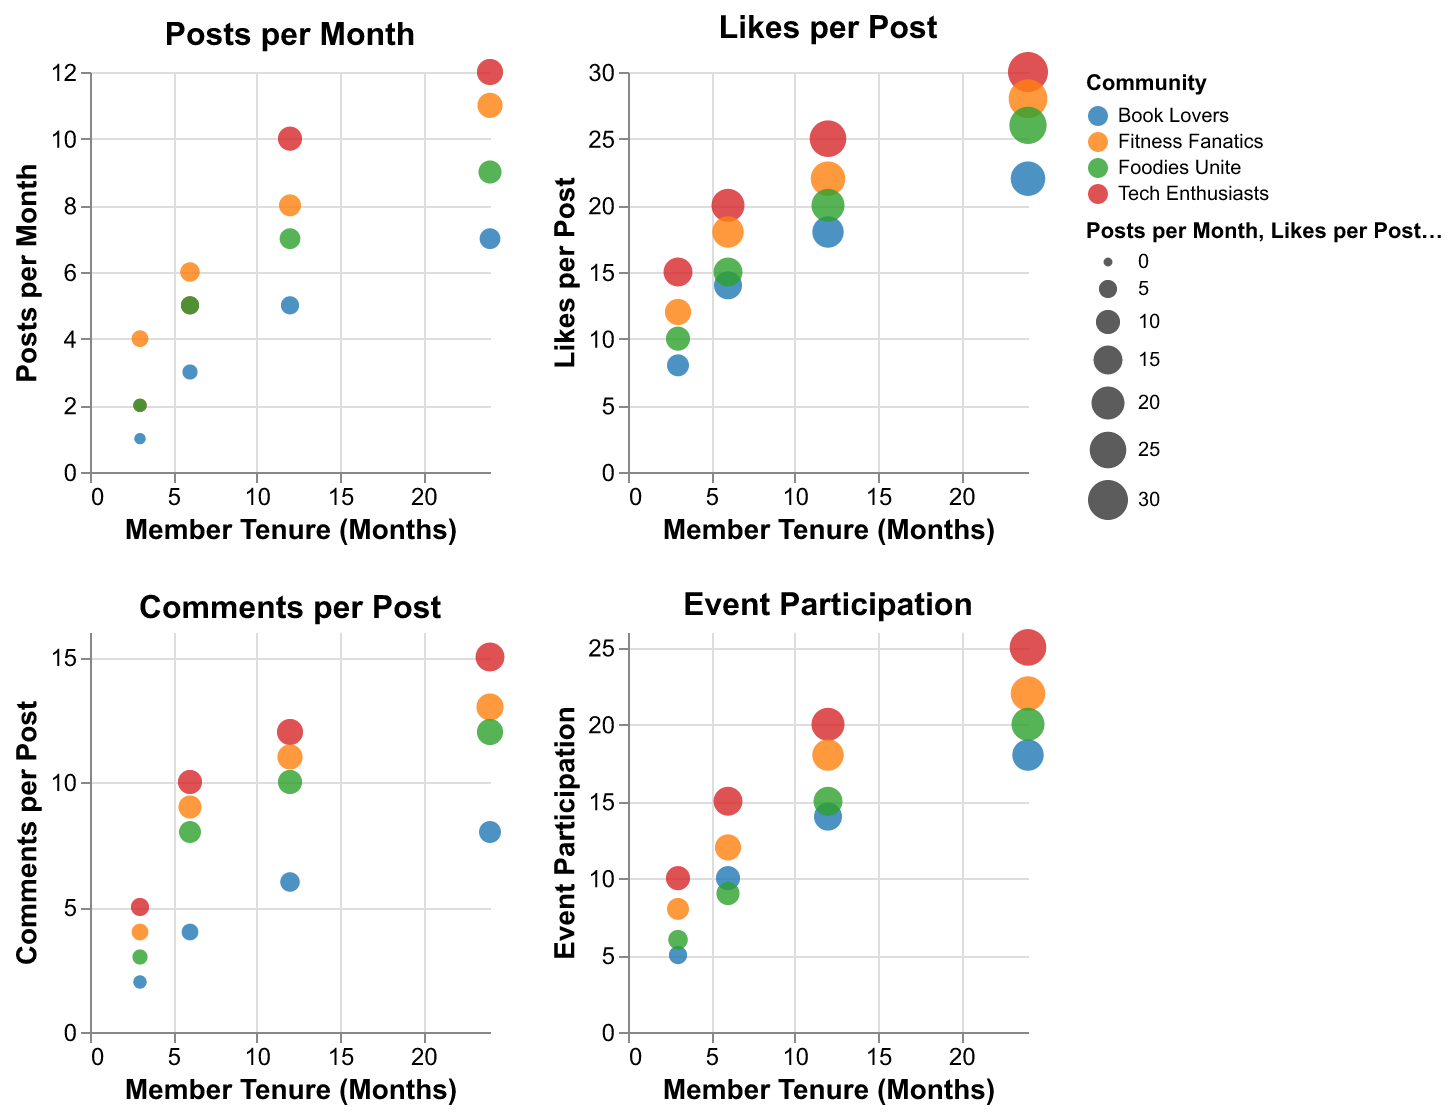What's the title of the leftmost plot? The title is presented at the top center of each individual subplot. For the leftmost plot, it reads "Posts per Month".
Answer: Posts per Month How many different communities are included in these plots? The color legend on the plots shows the distinct categories, representing different communities. There are four communities: Tech Enthusiasts, Fitness Fanatics, Book Lovers, and Foodies Unite.
Answer: Four Which community has the highest "Posts per Month" with a tenure of 12 months? Looking at the "Posts per Month" subplot, locate the data point where "Member Tenure (Months)" equals 12 and compare the values. "Tech Enthusiasts" has the highest value with 10.
Answer: Tech Enthusiasts For the "Fitness Fanatics" community, how does "Event Participation" change as member tenure increases from 3 to 24 months? On the "Event Participation" subplot, locate the data points for "Fitness Fanatics" and observe the values: 8 (3 months), 12 (6 months), 18 (12 months), and 22 (24 months). The values steadily increase.
Answer: Increases What is the difference in "Likes per Post" between members with 24 months and 3 months of tenure in the "Foodies Unite" community? In the "Likes per Post" subplot, identify the values for the "Foodies Unite" community at 24 and 3 months: 26 and 10, respectively. The difference is 26 - 10 = 16.
Answer: 16 Which community shows the highest "Comments per Post" with a tenure of 24 months? In the "Comments per Post" subplot, locate the data points for each community at 24 months and compare the values. "Tech Enthusiasts" shows the highest value with 15.
Answer: Tech Enthusiasts What is the average "Posts per Month" for the "Book Lovers" community over all tenures? Summing the "Posts per Month" values for "Book Lovers" (1, 3, 5, 7) and dividing by the number of data points (4), the average is (1 + 3 + 5 + 7) / 4 = 4.
Answer: 4 Which community sees the greatest increase in "Likes per Post" from 3 months to 24 months of tenure? Calculate the difference for each community between 3 and 24 months in the "Likes per Post" subplot: 
- Tech Enthusiasts: 30 - 15 = 15 
- Fitness Fanatics: 28 - 12 = 16 
- Book Lovers: 22 - 8 = 14 
- Foodies Unite: 26 - 10 = 16 
The greatest increase is tied between Fitness Fanatics and Foodies Unite with 16 each.
Answer: Fitness Fanatics, Foodies Unite Which community has the smallest bubble in the "Comments per Post" plot, and what does it represent? The smallest bubble in "Comments per Post" subplot is for "Book Lovers" at 3 months tenure. The value represented, observed via the smallest size, is 2.
Answer: Book Lovers, 2 